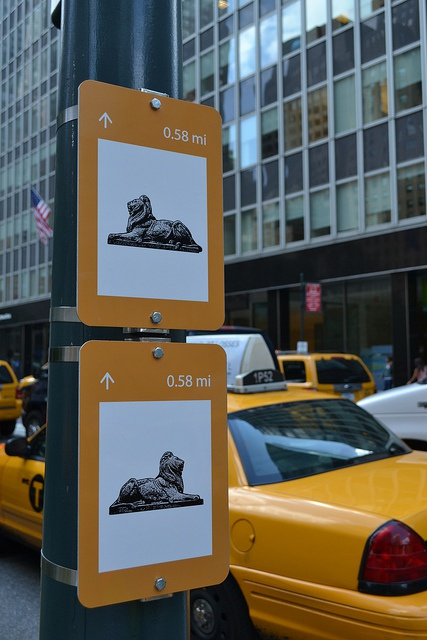Describe the objects in this image and their specific colors. I can see car in gray, black, olive, orange, and maroon tones, car in gray, black, olive, and tan tones, car in gray, darkgray, black, and lightblue tones, car in gray, black, olive, and maroon tones, and people in gray, black, maroon, and navy tones in this image. 